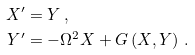Convert formula to latex. <formula><loc_0><loc_0><loc_500><loc_500>X ^ { \prime } & = Y \, , \\ Y ^ { \prime } & = - \Omega ^ { 2 } X + G \left ( X , Y \right ) \, .</formula> 